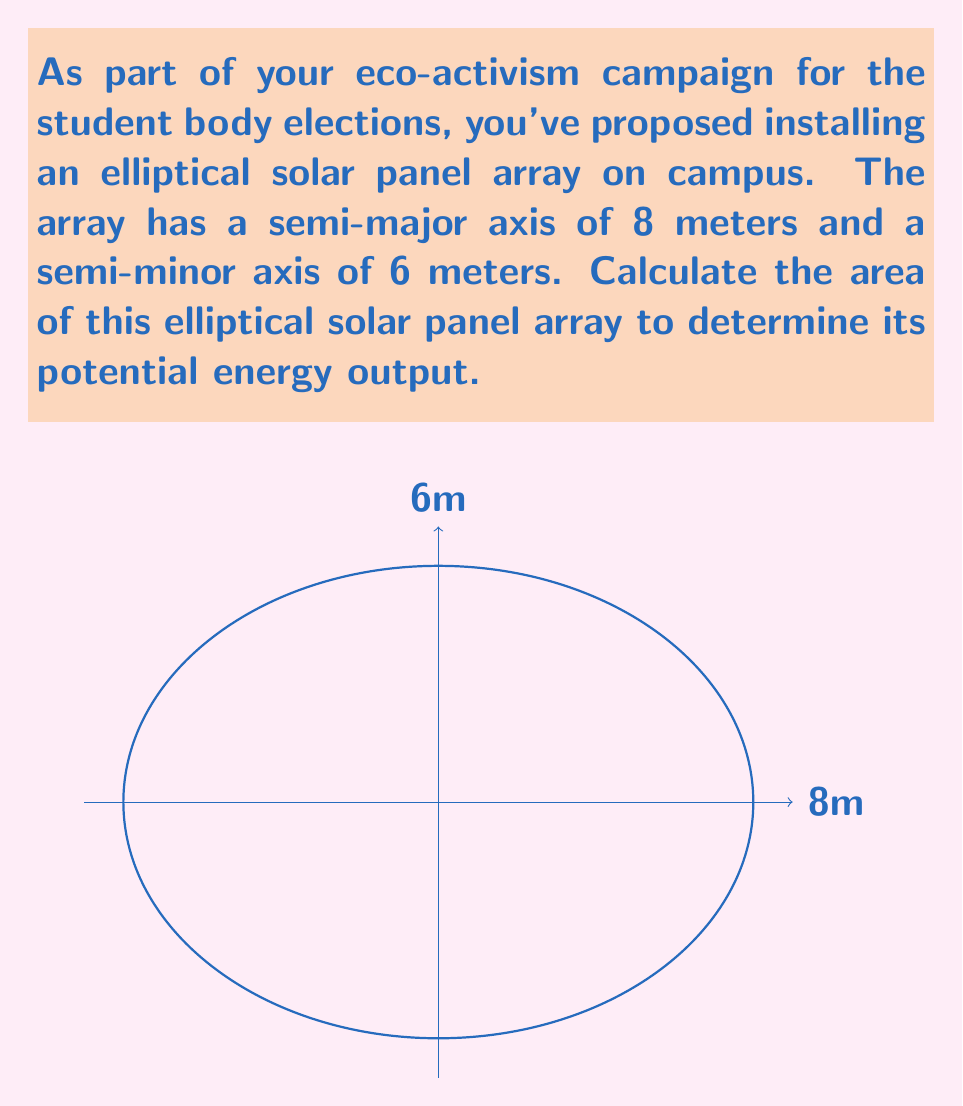Could you help me with this problem? To calculate the area of an ellipse, we use the formula:

$$ A = \pi ab $$

Where:
$a$ is the length of the semi-major axis
$b$ is the length of the semi-minor axis

Given:
$a = 8$ meters
$b = 6$ meters

Step 1: Substitute the values into the formula:
$$ A = \pi (8)(6) $$

Step 2: Multiply the values inside the parentheses:
$$ A = \pi (48) $$

Step 3: Multiply by π:
$$ A = 48\pi \approx 150.80 \text{ m}^2 $$

Therefore, the area of the elliptical solar panel array is approximately 150.80 square meters.
Answer: $48\pi \text{ m}^2$ or approximately $150.80 \text{ m}^2$ 